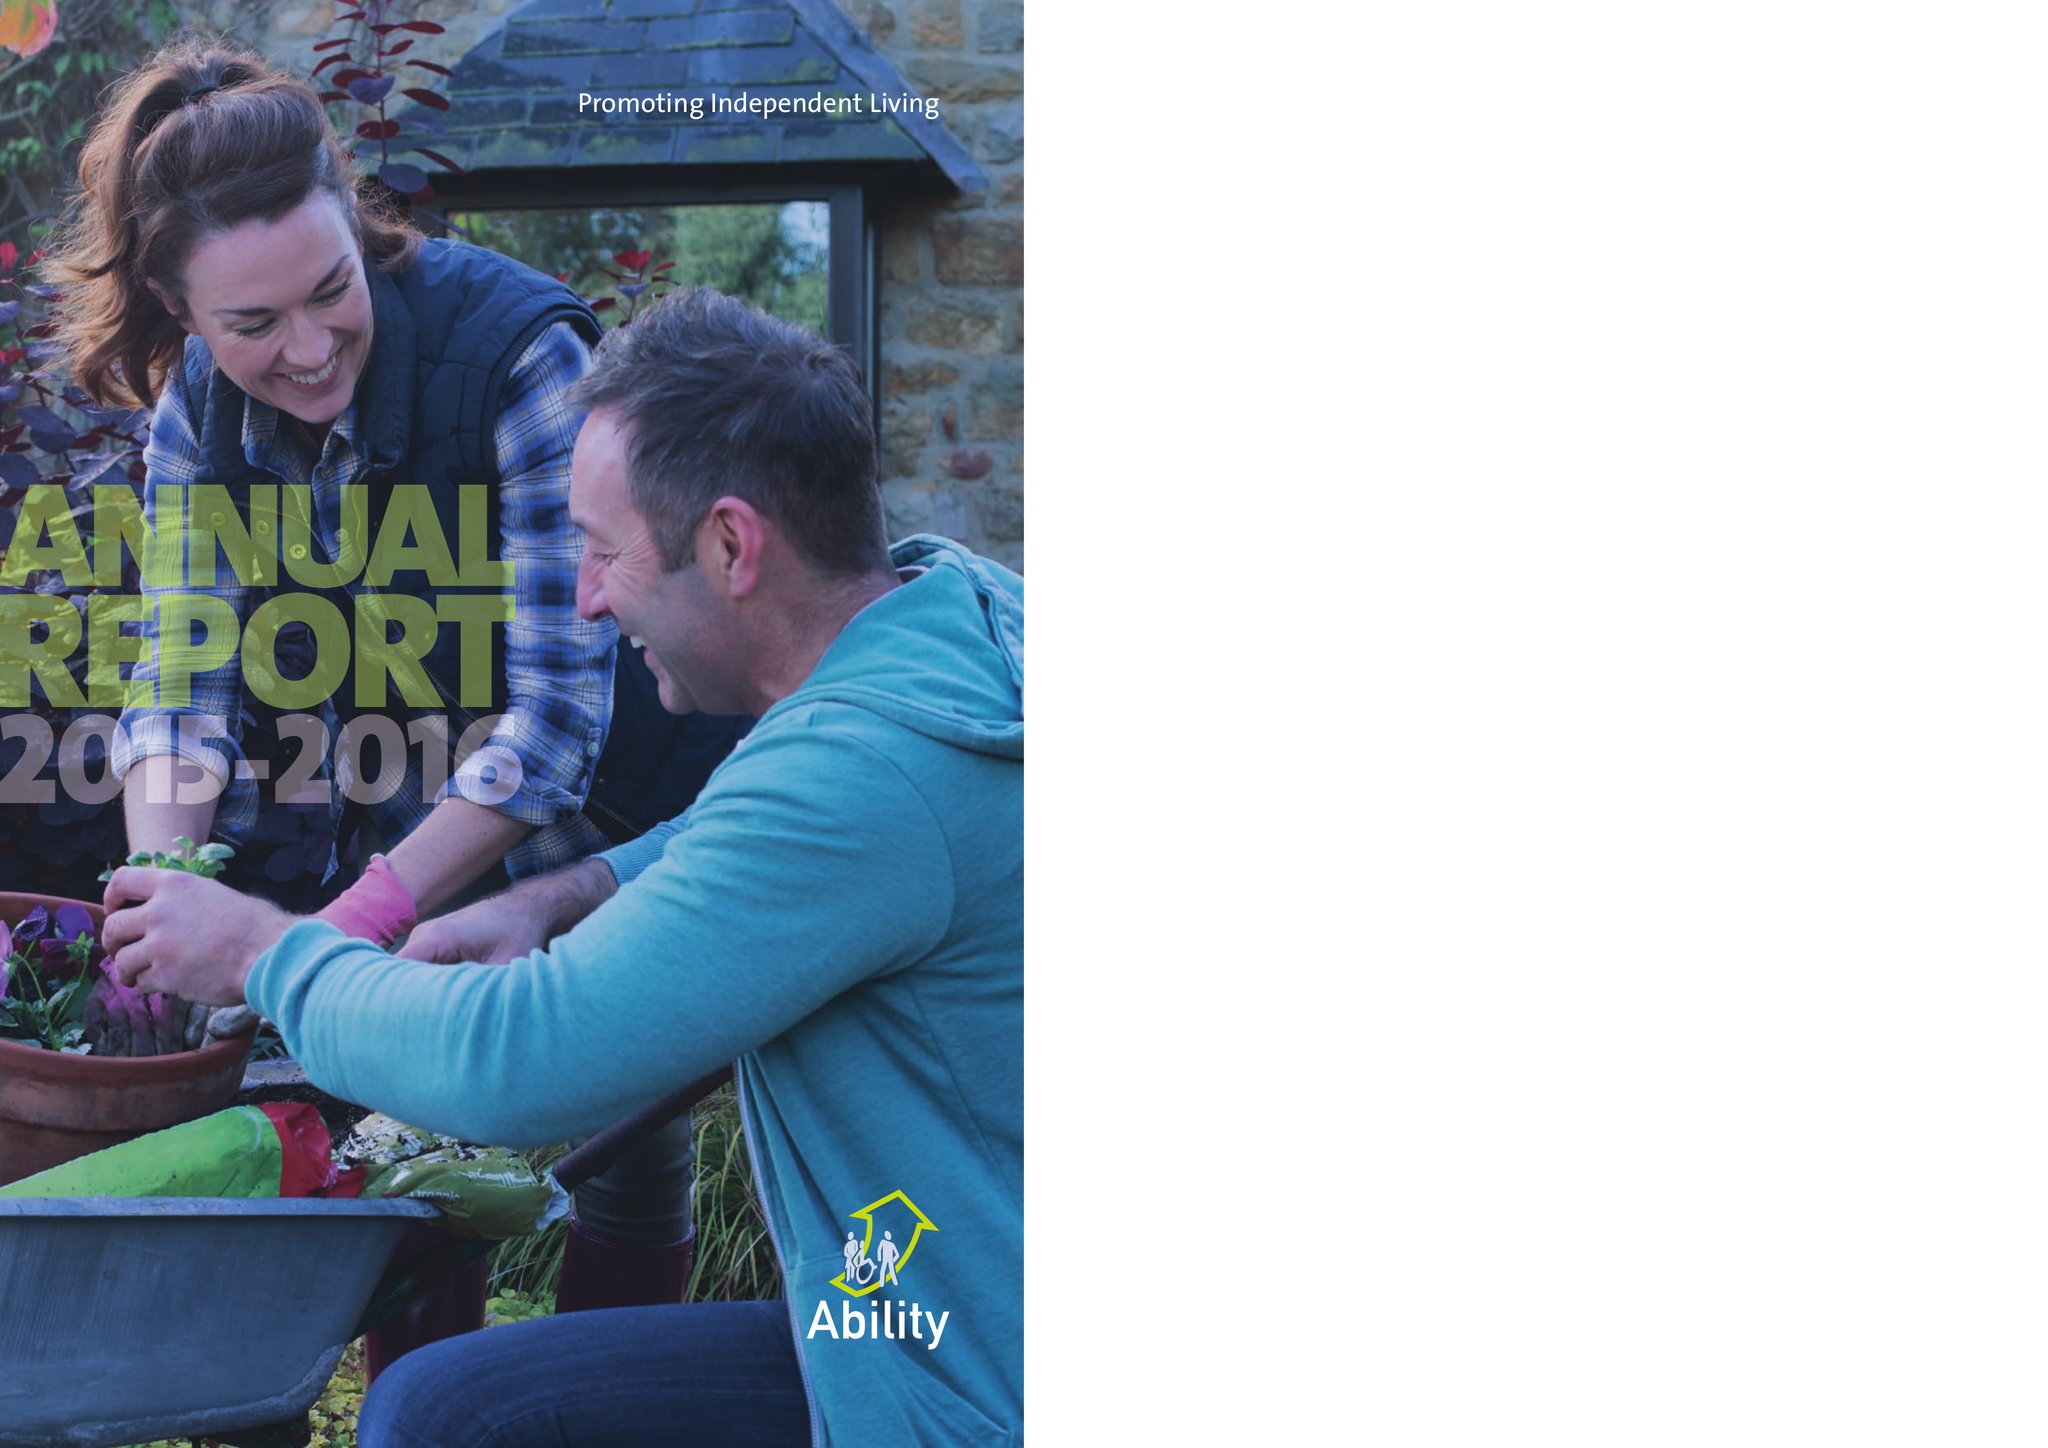What is the value for the income_annually_in_british_pounds?
Answer the question using a single word or phrase. 13671352.00 